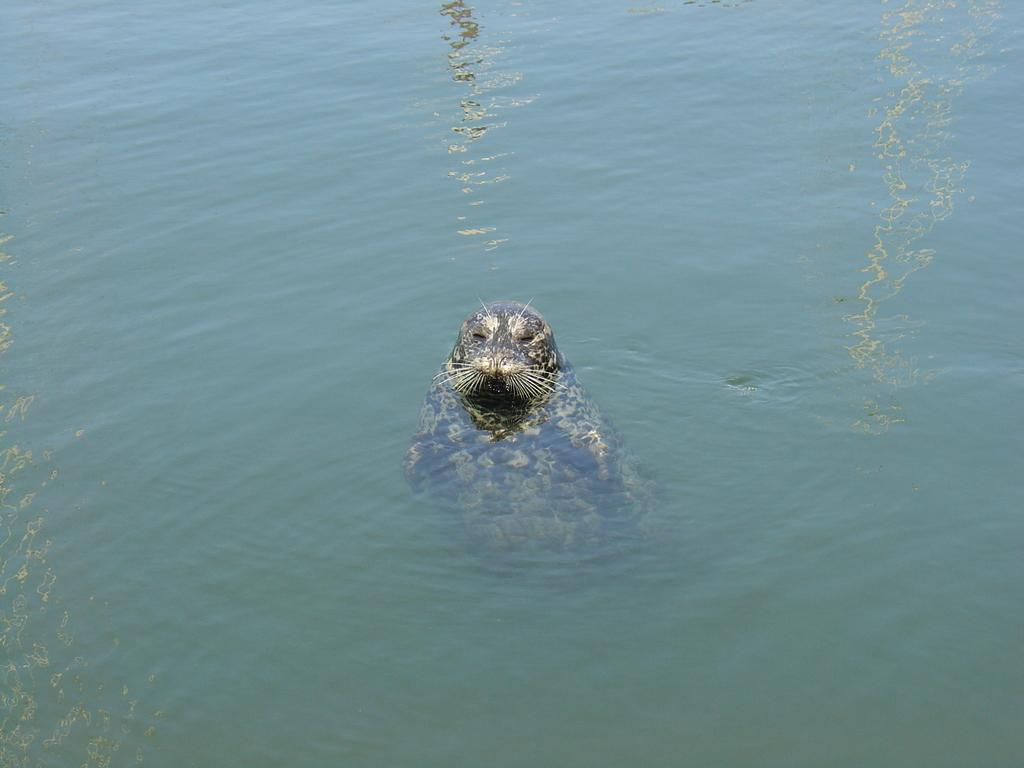What type of animal can be seen in the image? There is a seal in the water in the image. Where is the seal located in the image? The seal is in the water in the image. What type of mountain can be seen in the image? There is no mountain present in the image; it features a seal in the water. How much sugar is dissolved in the water in the image? There is no information about sugar in the image, as it only features a seal in the water. 